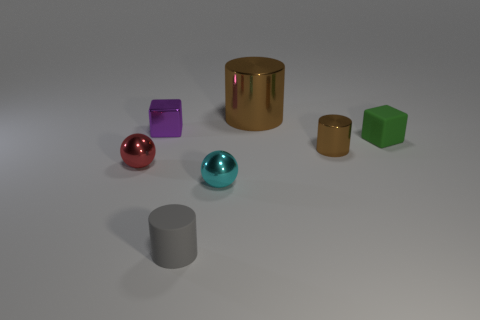There is a ball that is right of the tiny purple cube; is its size the same as the brown metal object that is in front of the purple block?
Your response must be concise. Yes. How many tiny things are either red metal cylinders or cyan balls?
Make the answer very short. 1. What is the material of the brown object behind the block that is on the right side of the small rubber cylinder?
Your response must be concise. Metal. What is the shape of the big metallic thing that is the same color as the small metallic cylinder?
Give a very brief answer. Cylinder. Are there any tiny red balls that have the same material as the tiny purple thing?
Keep it short and to the point. Yes. Is the tiny purple thing made of the same material as the tiny sphere left of the matte cylinder?
Provide a succinct answer. Yes. What is the color of the rubber object that is the same size as the rubber cube?
Make the answer very short. Gray. What is the size of the brown cylinder in front of the brown metal object behind the small purple metal cube?
Provide a succinct answer. Small. There is a big thing; is its color the same as the metallic cylinder in front of the tiny metallic block?
Give a very brief answer. Yes. Is the number of tiny rubber cylinders on the right side of the small purple thing less than the number of spheres?
Offer a terse response. Yes. 